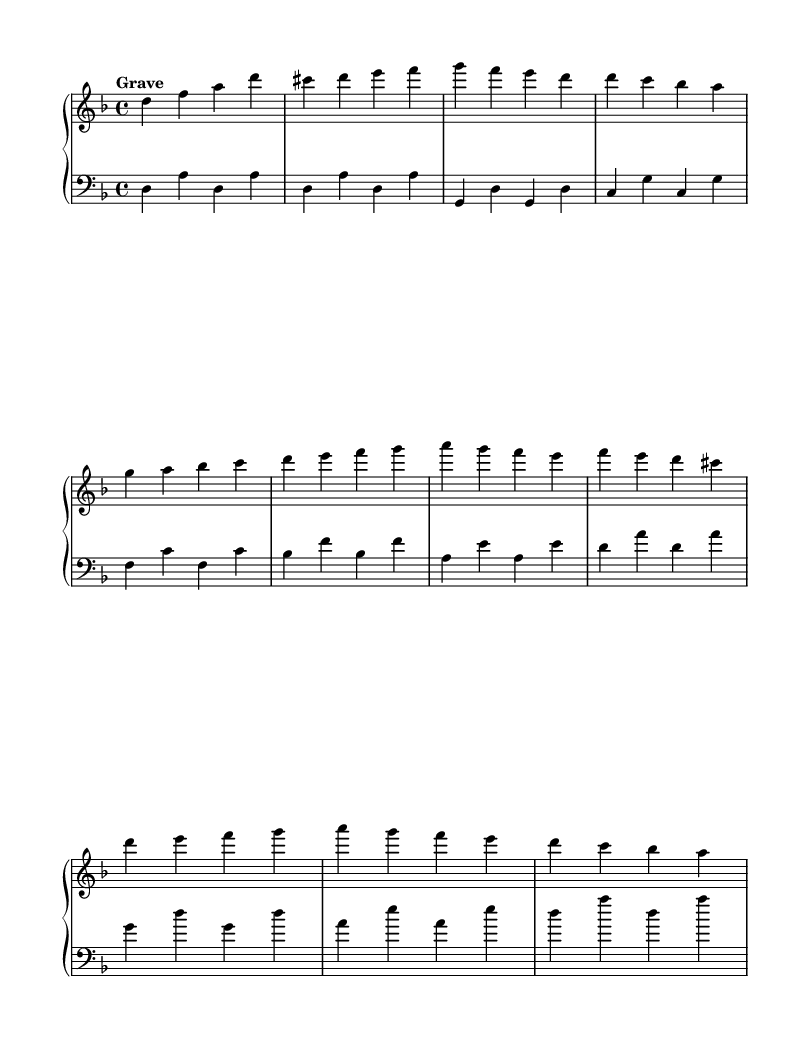What is the key signature of this music? The key signature is D minor, which has one flat, represented by the B flat on the staff.
Answer: D minor What is the time signature of this piece? The time signature is 4/4, indicated by the "4" over "4," which means there are four beats in a measure, and a quarter note gets one beat.
Answer: 4/4 What is the tempo marking for this piece? The tempo marking is "Grave," which indicates the piece should be played slowly and solemnly.
Answer: Grave How many themes are presented in the music? There are two distinct themes labeled as Theme A and Theme B, which can be identified in the upper staff.
Answer: Two In which clefs are the upper and lower staves written? The upper staff is written in the treble clef, while the lower staff is written in the bass clef. This notation helps denote the pitch ranges for the piano.
Answer: Treble and bass clefs What type of musical form is predominantly reflected here based on the themes? The music exhibits a binary form, which is suggested by the clear distinction between Theme A and Theme B without extensive development.
Answer: Binary form How many measures does the primary material occupy? The primary material, which includes both themes and some placeholder transitions, occupies a total of 16 measures, as noted by the vertical bar lines.
Answer: Sixteen measures 